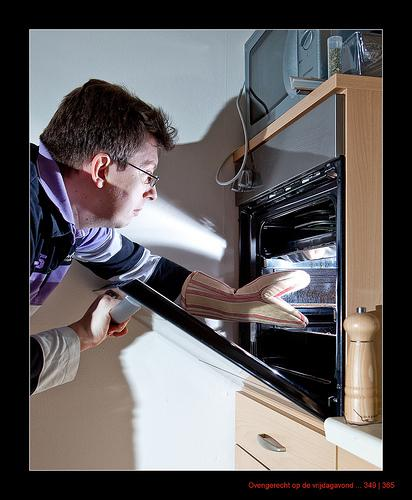Mention the key figure and the main action they are performing in the picture. A man wearing glasses and an oven mitt is reaching into an open oven. Recount the chief persona and their ongoing task in the frame. Man sporting glasses and an oven mitt with stripes is interacting with an open oven situated near a pepper grinder. Pithily recount the protagonist and the activity they're executing in the depiction. A bespectacled fellow, equipped with a decorative oven mitt, retrieves something from an open oven stationed by a pepper canister. Briefly highlight the main character and their action in the visual. Glasses-clad man utilizes a multicolored oven mitt to access the interior of a kitchen appliance. Write a single sentence describing the most significant elements in the image. A man wearing glasses and a striped oven mitt reaches into an open oven, as a wooden pepper grinder rests on the nearby counter. Provide a brief overview of the scenario depicted in the image. A middle-aged man in glasses uses a striped oven mitt to reach inside an oven, with a wooden pepper dispenser on the counter. Give a succinct description of the main individual and their current undertaking in the picture. A man donning eyewear and a patterned glove is handling contents within an oven, adjacent to a wooden pepper mill. Explain the main focus of the image in a concise manner. Man in glasses uses a patterned oven mitt to pull something out of an open oven, next to a wooden pepper shaker on the countertop. Comment on the key subject in the photo and what is happening. The man with spectacles and a colorful oven mitt is reaching into an open oven while a pepper dispenser stands on the counter. Describe the primary figure and their activity in the snapshot. A bespectacled man adorned with a striped protective glove is in the process of extracting something from an oven. 